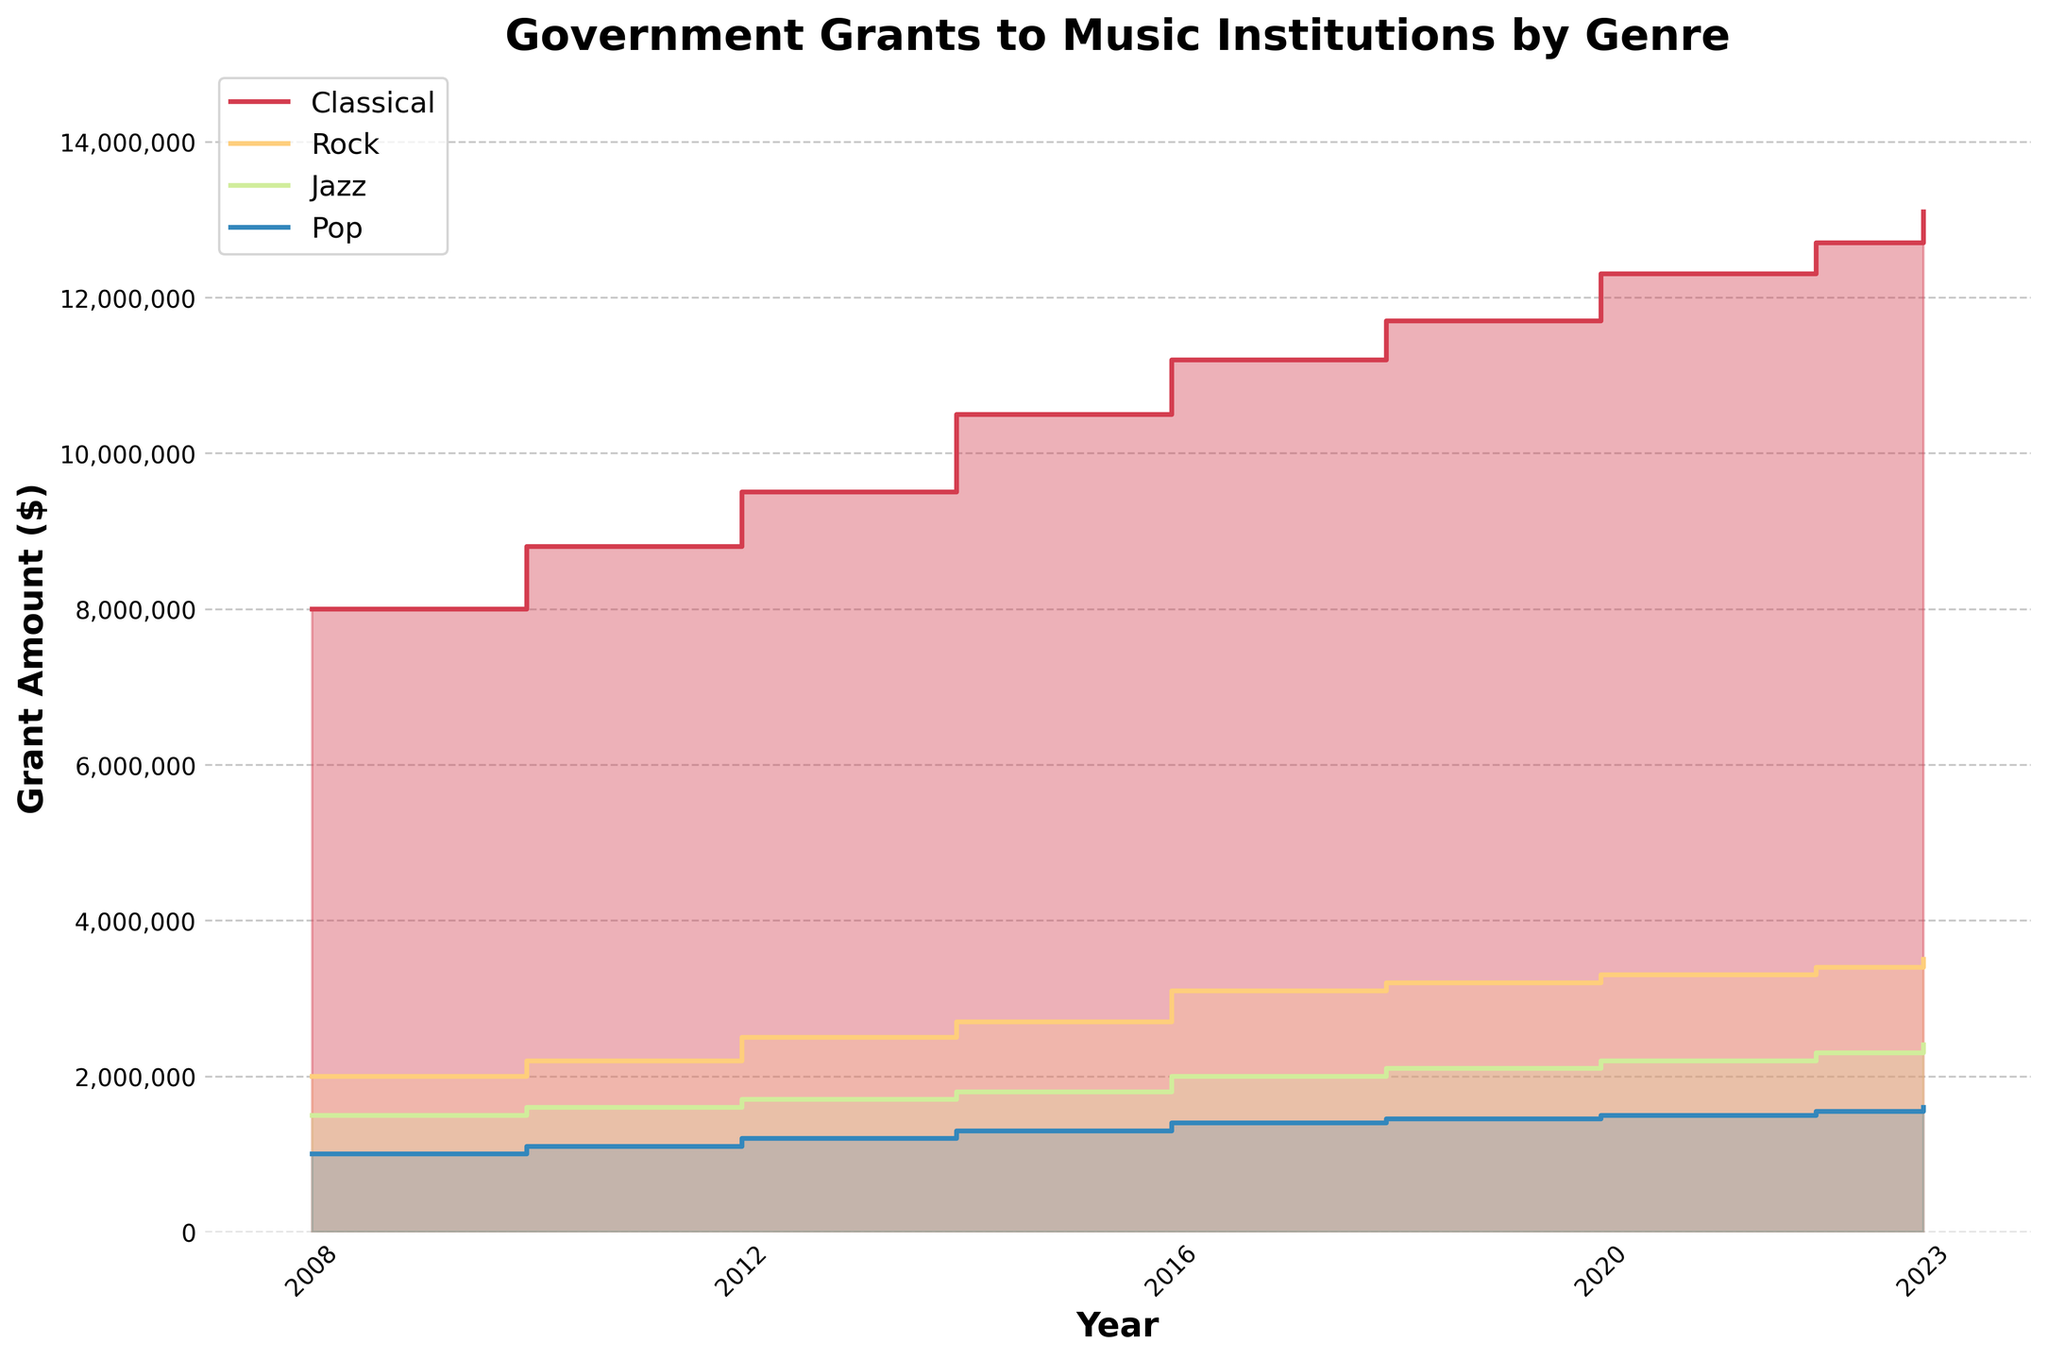What is the title of the chart? The title of the chart is located at the top and is in bold, indicating the subject of the data being visualized. It reads "Government Grants to Music Institutions by Genre."
Answer: Government Grants to Music Institutions by Genre Which genre received the highest grant amount in 2023? By looking at the step area chart for the year 2023, the genre with the highest peak in the graph would indicate the highest grant amount. The "Classical" genre shows the highest peak.
Answer: Classical What is the range of years displayed in this chart? The X-axis represents the years, starting from the leftmost year to the rightmost year. The chart displays data from 2008 to 2023.
Answer: 2008 to 2023 How much did the government grants for Jazz increase from 2008 to 2023? To determine the increase in government grants for Jazz, find the grant amounts for Jazz in 2008 and 2023 from the chart and calculate the difference. The amounts are $1,500,000 in 2008 and $2,400,000 in 2023. Subtract the former from the latter: $2,400,000 - $1,500,000 = $900,000.
Answer: $900,000 Compare the trend of grant amounts over the years for the Classical genre and the Rock genre. Examine the step patterns for both Classical and Rock genres over the years. Classical consistently shows an increase over the years, whereas Rock also increases but at a slower rate compared to Classical.
Answer: Classical increases steadily; Rock increases more slowly What is the total grant amount awarded to Classical music institutions in 2018? Sum the individual grant amounts for Classical institutions in 2018, which are $7,200,000 for the Metropolitan Opera and $4,500,000 for the Berlin Philharmonic. The total is $7,200,000 + $4,500,000 = $11,700,000.
Answer: $11,700,000 Which genre's grant amount showed the least amount of change from 2008 to 2023? Find the difference in grant amounts from 2008 to 2023 for each genre and compare. The Pop genre, starting at $1,000,000 in 2008 and rising to $1,600,000 in 2023, shows the least change ($600,000).
Answer: Pop What is the difference in grant amount between Classical and Pop in 2020? Subtract the grant amount for Pop from the grant amount for Classical in 2020. Classical has $12,300,000 ($7,500,000 + $4,800,000) and Pop has $1,500,000, giving $12,300,000 - $1,500,000 = $10,800,000.
Answer: $10,800,000 